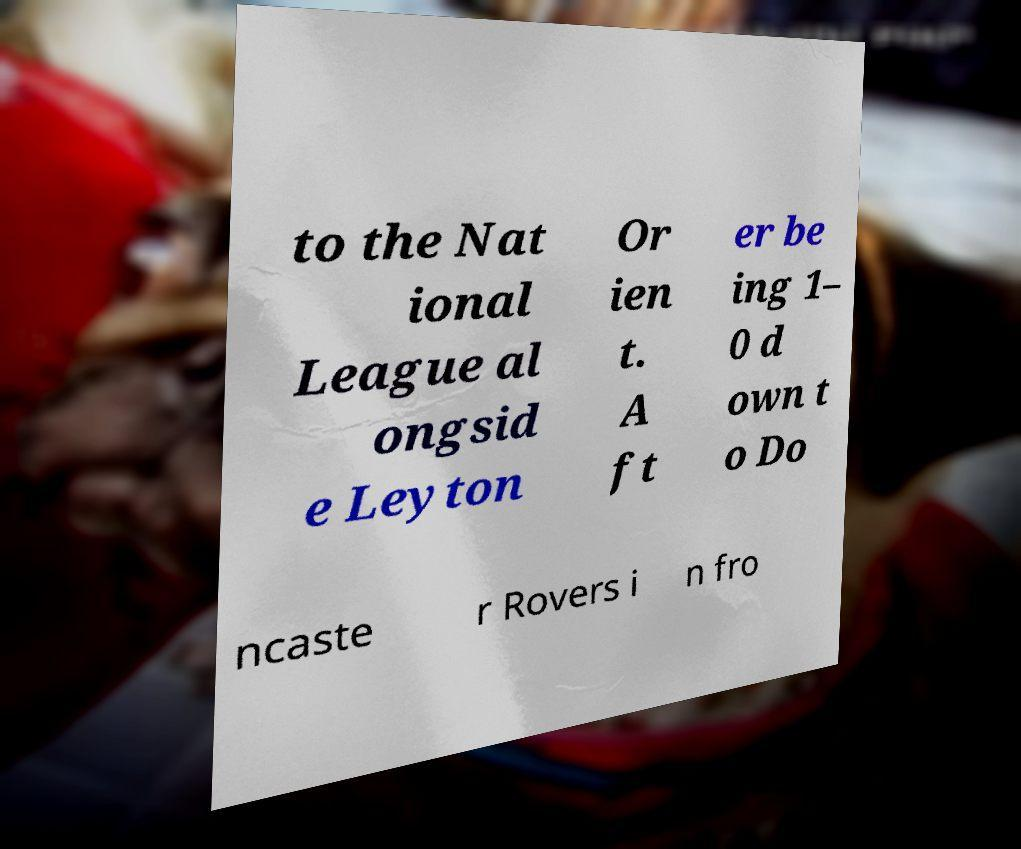There's text embedded in this image that I need extracted. Can you transcribe it verbatim? to the Nat ional League al ongsid e Leyton Or ien t. A ft er be ing 1– 0 d own t o Do ncaste r Rovers i n fro 